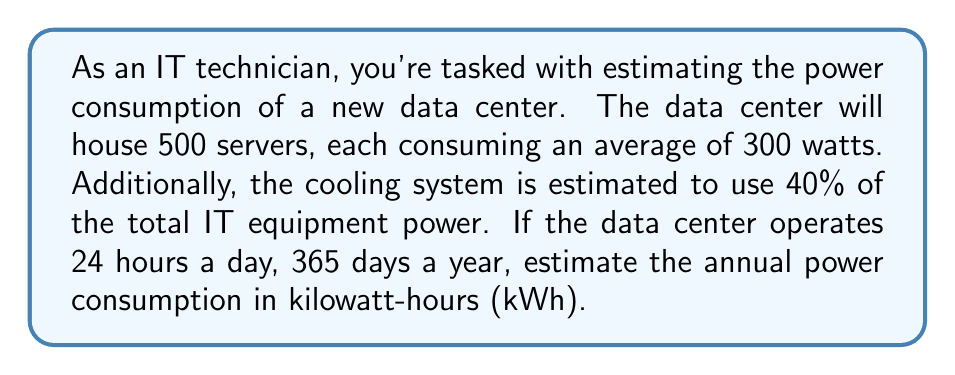Can you solve this math problem? Let's break this down step-by-step:

1. Calculate the total power consumption of the servers:
   $$ P_{servers} = 500 \text{ servers} \times 300 \text{ watts} = 150,000 \text{ watts} = 150 \text{ kW} $$

2. Calculate the power consumption of the cooling system:
   $$ P_{cooling} = 40\% \text{ of } P_{servers} = 0.4 \times 150 \text{ kW} = 60 \text{ kW} $$

3. Calculate the total power consumption:
   $$ P_{total} = P_{servers} + P_{cooling} = 150 \text{ kW} + 60 \text{ kW} = 210 \text{ kW} $$

4. Calculate the annual power consumption in kWh:
   $$ E_{annual} = P_{total} \times \text{hours per day} \times \text{days per year} $$
   $$ E_{annual} = 210 \text{ kW} \times 24 \text{ hours} \times 365 \text{ days} = 1,839,600 \text{ kWh} $$
Answer: The estimated annual power consumption of the data center is 1,839,600 kWh. 